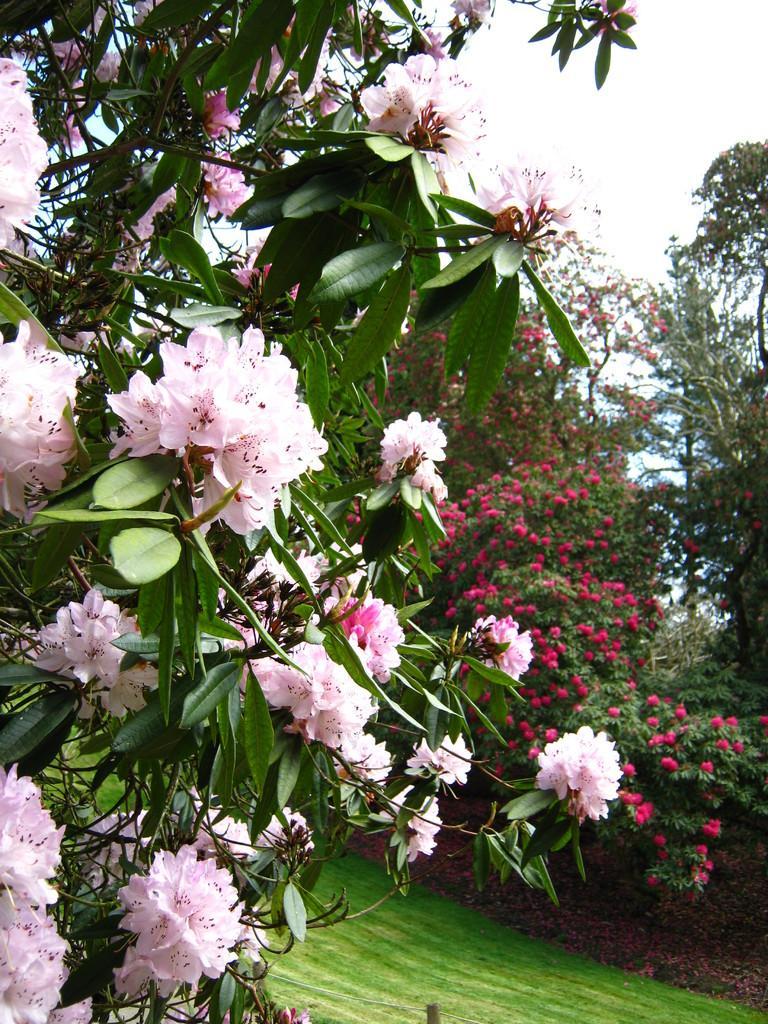Describe this image in one or two sentences. In this image I can see number of pink colour flowers and leaves in the front. In the background I can see grass ground and number of trees. 